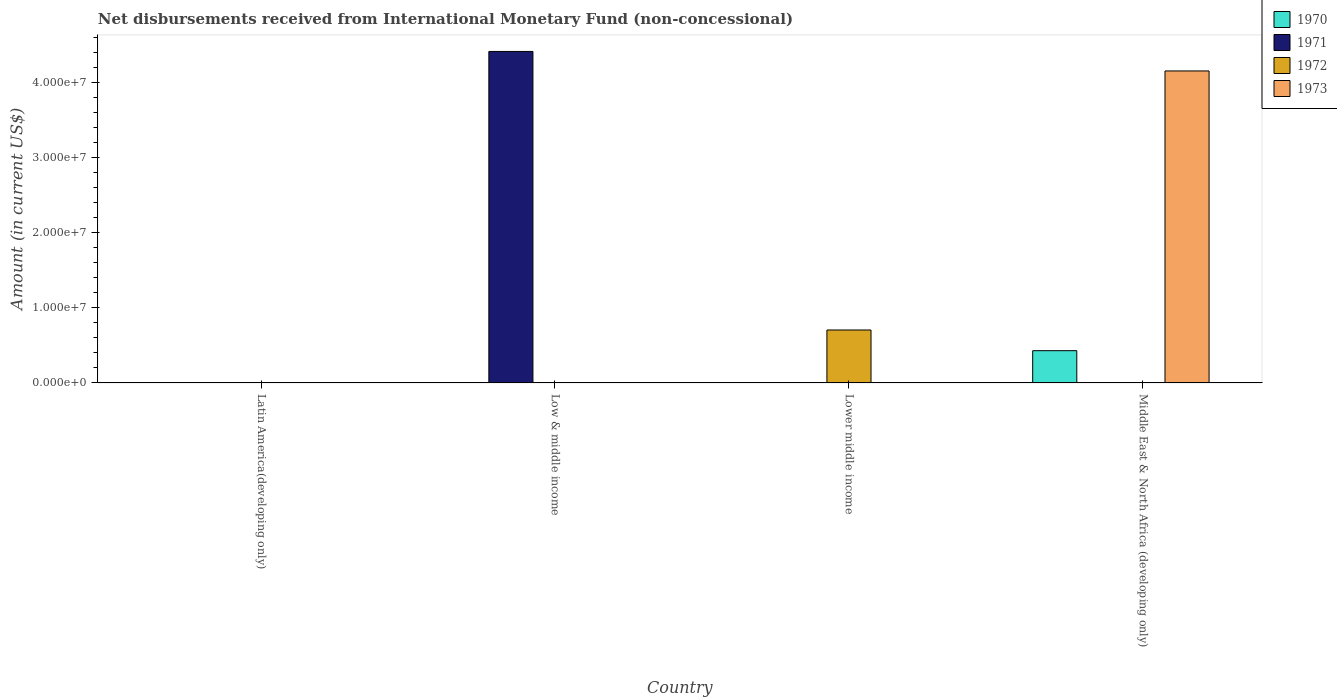How many different coloured bars are there?
Your answer should be compact. 4. Are the number of bars per tick equal to the number of legend labels?
Ensure brevity in your answer.  No. How many bars are there on the 2nd tick from the right?
Your response must be concise. 1. What is the label of the 2nd group of bars from the left?
Offer a very short reply. Low & middle income. In how many cases, is the number of bars for a given country not equal to the number of legend labels?
Keep it short and to the point. 4. What is the amount of disbursements received from International Monetary Fund in 1971 in Lower middle income?
Make the answer very short. 0. Across all countries, what is the maximum amount of disbursements received from International Monetary Fund in 1970?
Give a very brief answer. 4.30e+06. In which country was the amount of disbursements received from International Monetary Fund in 1972 maximum?
Your answer should be very brief. Lower middle income. What is the total amount of disbursements received from International Monetary Fund in 1971 in the graph?
Keep it short and to the point. 4.42e+07. What is the difference between the amount of disbursements received from International Monetary Fund in 1971 in Low & middle income and the amount of disbursements received from International Monetary Fund in 1970 in Middle East & North Africa (developing only)?
Your answer should be very brief. 3.99e+07. What is the average amount of disbursements received from International Monetary Fund in 1970 per country?
Provide a short and direct response. 1.08e+06. In how many countries, is the amount of disbursements received from International Monetary Fund in 1971 greater than 24000000 US$?
Your answer should be compact. 1. What is the difference between the highest and the lowest amount of disbursements received from International Monetary Fund in 1972?
Give a very brief answer. 7.06e+06. Is it the case that in every country, the sum of the amount of disbursements received from International Monetary Fund in 1973 and amount of disbursements received from International Monetary Fund in 1972 is greater than the sum of amount of disbursements received from International Monetary Fund in 1971 and amount of disbursements received from International Monetary Fund in 1970?
Provide a succinct answer. No. Is it the case that in every country, the sum of the amount of disbursements received from International Monetary Fund in 1972 and amount of disbursements received from International Monetary Fund in 1970 is greater than the amount of disbursements received from International Monetary Fund in 1971?
Your answer should be compact. No. How many bars are there?
Your response must be concise. 4. How many countries are there in the graph?
Make the answer very short. 4. Does the graph contain grids?
Give a very brief answer. No. How are the legend labels stacked?
Ensure brevity in your answer.  Vertical. What is the title of the graph?
Make the answer very short. Net disbursements received from International Monetary Fund (non-concessional). Does "1963" appear as one of the legend labels in the graph?
Your response must be concise. No. What is the Amount (in current US$) of 1971 in Latin America(developing only)?
Give a very brief answer. 0. What is the Amount (in current US$) of 1972 in Latin America(developing only)?
Provide a succinct answer. 0. What is the Amount (in current US$) in 1971 in Low & middle income?
Provide a short and direct response. 4.42e+07. What is the Amount (in current US$) of 1972 in Low & middle income?
Offer a very short reply. 0. What is the Amount (in current US$) in 1973 in Low & middle income?
Offer a terse response. 0. What is the Amount (in current US$) in 1970 in Lower middle income?
Your response must be concise. 0. What is the Amount (in current US$) in 1971 in Lower middle income?
Offer a very short reply. 0. What is the Amount (in current US$) of 1972 in Lower middle income?
Provide a succinct answer. 7.06e+06. What is the Amount (in current US$) in 1970 in Middle East & North Africa (developing only)?
Make the answer very short. 4.30e+06. What is the Amount (in current US$) of 1973 in Middle East & North Africa (developing only)?
Make the answer very short. 4.16e+07. Across all countries, what is the maximum Amount (in current US$) in 1970?
Your response must be concise. 4.30e+06. Across all countries, what is the maximum Amount (in current US$) in 1971?
Ensure brevity in your answer.  4.42e+07. Across all countries, what is the maximum Amount (in current US$) in 1972?
Make the answer very short. 7.06e+06. Across all countries, what is the maximum Amount (in current US$) of 1973?
Your answer should be very brief. 4.16e+07. Across all countries, what is the minimum Amount (in current US$) of 1970?
Ensure brevity in your answer.  0. Across all countries, what is the minimum Amount (in current US$) in 1971?
Provide a short and direct response. 0. What is the total Amount (in current US$) of 1970 in the graph?
Provide a short and direct response. 4.30e+06. What is the total Amount (in current US$) of 1971 in the graph?
Make the answer very short. 4.42e+07. What is the total Amount (in current US$) in 1972 in the graph?
Offer a very short reply. 7.06e+06. What is the total Amount (in current US$) in 1973 in the graph?
Offer a terse response. 4.16e+07. What is the difference between the Amount (in current US$) of 1971 in Low & middle income and the Amount (in current US$) of 1972 in Lower middle income?
Your response must be concise. 3.71e+07. What is the difference between the Amount (in current US$) in 1971 in Low & middle income and the Amount (in current US$) in 1973 in Middle East & North Africa (developing only)?
Make the answer very short. 2.60e+06. What is the difference between the Amount (in current US$) in 1972 in Lower middle income and the Amount (in current US$) in 1973 in Middle East & North Africa (developing only)?
Offer a terse response. -3.45e+07. What is the average Amount (in current US$) in 1970 per country?
Provide a succinct answer. 1.08e+06. What is the average Amount (in current US$) of 1971 per country?
Keep it short and to the point. 1.10e+07. What is the average Amount (in current US$) of 1972 per country?
Keep it short and to the point. 1.76e+06. What is the average Amount (in current US$) in 1973 per country?
Provide a short and direct response. 1.04e+07. What is the difference between the Amount (in current US$) in 1970 and Amount (in current US$) in 1973 in Middle East & North Africa (developing only)?
Ensure brevity in your answer.  -3.73e+07. What is the difference between the highest and the lowest Amount (in current US$) of 1970?
Provide a short and direct response. 4.30e+06. What is the difference between the highest and the lowest Amount (in current US$) in 1971?
Keep it short and to the point. 4.42e+07. What is the difference between the highest and the lowest Amount (in current US$) of 1972?
Offer a terse response. 7.06e+06. What is the difference between the highest and the lowest Amount (in current US$) in 1973?
Ensure brevity in your answer.  4.16e+07. 